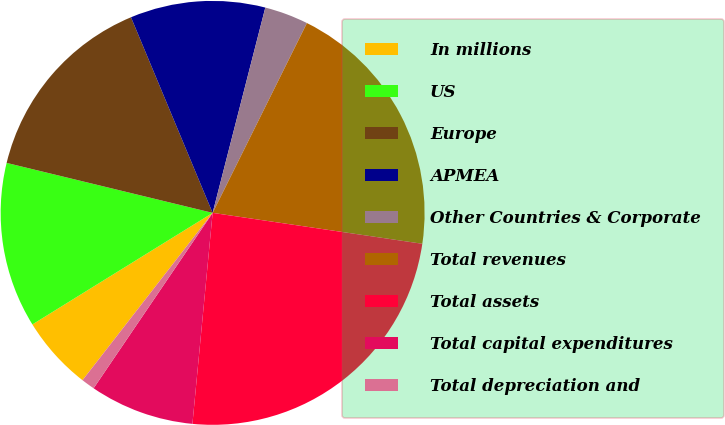Convert chart. <chart><loc_0><loc_0><loc_500><loc_500><pie_chart><fcel>In millions<fcel>US<fcel>Europe<fcel>APMEA<fcel>Other Countries & Corporate<fcel>Total revenues<fcel>Total assets<fcel>Total capital expenditures<fcel>Total depreciation and<nl><fcel>5.66%<fcel>12.61%<fcel>14.92%<fcel>10.29%<fcel>3.34%<fcel>19.99%<fcel>24.19%<fcel>7.97%<fcel>1.03%<nl></chart> 